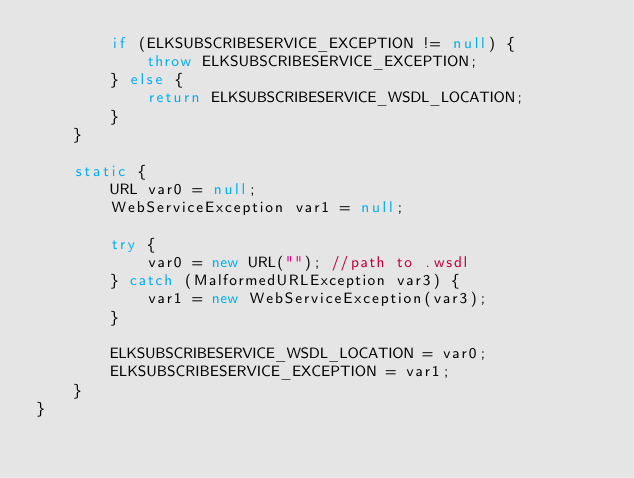Convert code to text. <code><loc_0><loc_0><loc_500><loc_500><_Java_>        if (ELKSUBSCRIBESERVICE_EXCEPTION != null) {
            throw ELKSUBSCRIBESERVICE_EXCEPTION;
        } else {
            return ELKSUBSCRIBESERVICE_WSDL_LOCATION;
        }
    }

    static {
        URL var0 = null;
        WebServiceException var1 = null;

        try {
            var0 = new URL(""); //path to .wsdl
        } catch (MalformedURLException var3) {
            var1 = new WebServiceException(var3);
        }

        ELKSUBSCRIBESERVICE_WSDL_LOCATION = var0;
        ELKSUBSCRIBESERVICE_EXCEPTION = var1;
    }
}
</code> 